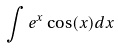<formula> <loc_0><loc_0><loc_500><loc_500>\int e ^ { x } \cos ( x ) d x</formula> 